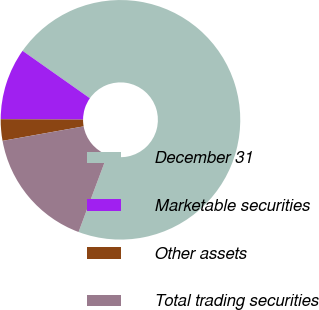Convert chart to OTSL. <chart><loc_0><loc_0><loc_500><loc_500><pie_chart><fcel>December 31<fcel>Marketable securities<fcel>Other assets<fcel>Total trading securities<nl><fcel>70.92%<fcel>9.69%<fcel>2.89%<fcel>16.5%<nl></chart> 